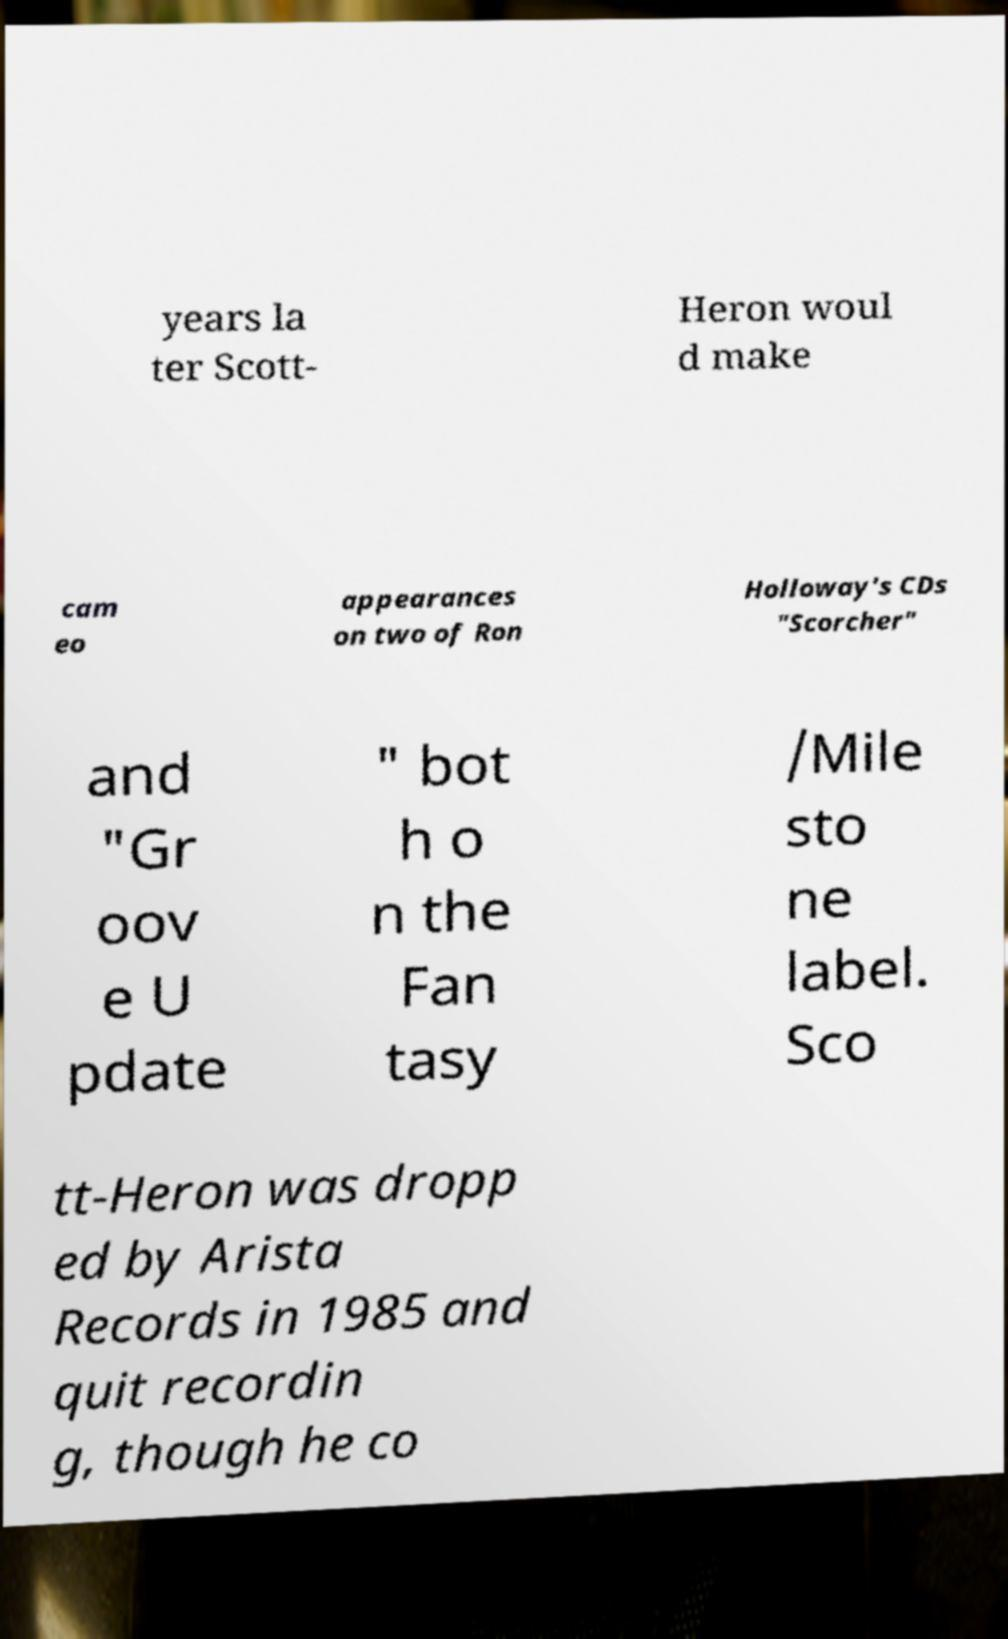Please identify and transcribe the text found in this image. years la ter Scott- Heron woul d make cam eo appearances on two of Ron Holloway's CDs "Scorcher" and "Gr oov e U pdate " bot h o n the Fan tasy /Mile sto ne label. Sco tt-Heron was dropp ed by Arista Records in 1985 and quit recordin g, though he co 